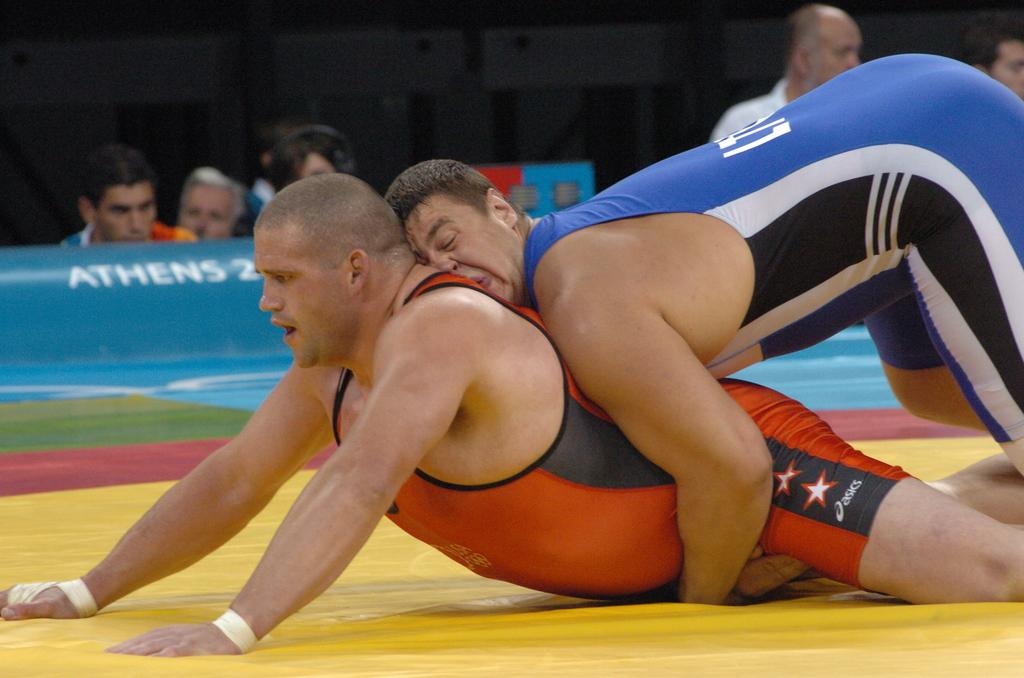<image>
Summarize the visual content of the image. Two men are seen wrestling on the matt during the Athens Olympics. 